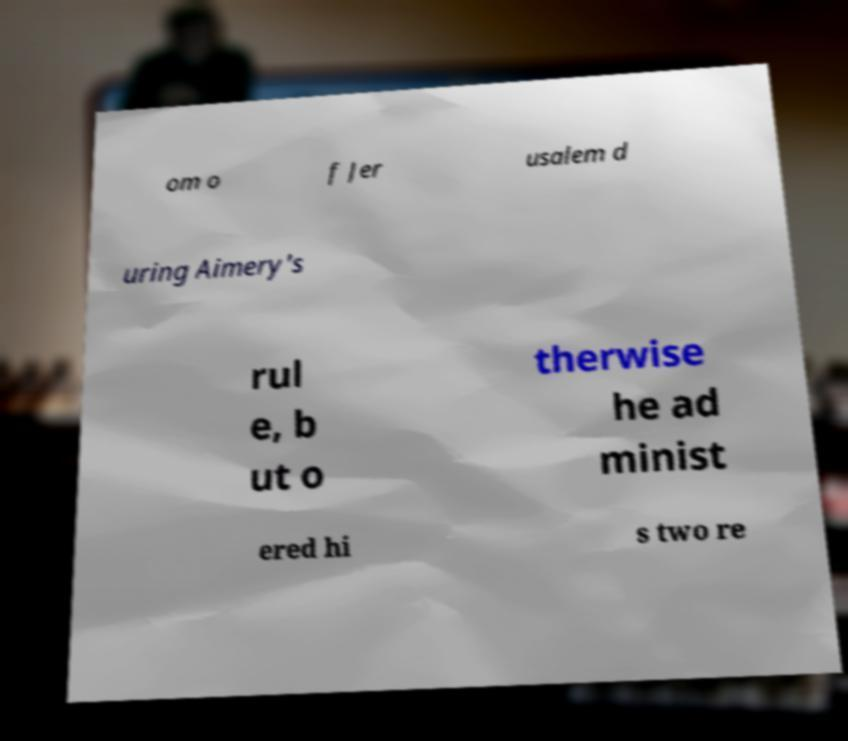What messages or text are displayed in this image? I need them in a readable, typed format. om o f Jer usalem d uring Aimery's rul e, b ut o therwise he ad minist ered hi s two re 